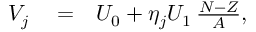Convert formula to latex. <formula><loc_0><loc_0><loc_500><loc_500>\begin{array} { r l r } { V _ { j } } & = } & { U _ { 0 } + \eta _ { j } U _ { 1 } \, \frac { N - Z } { A } , } \end{array}</formula> 